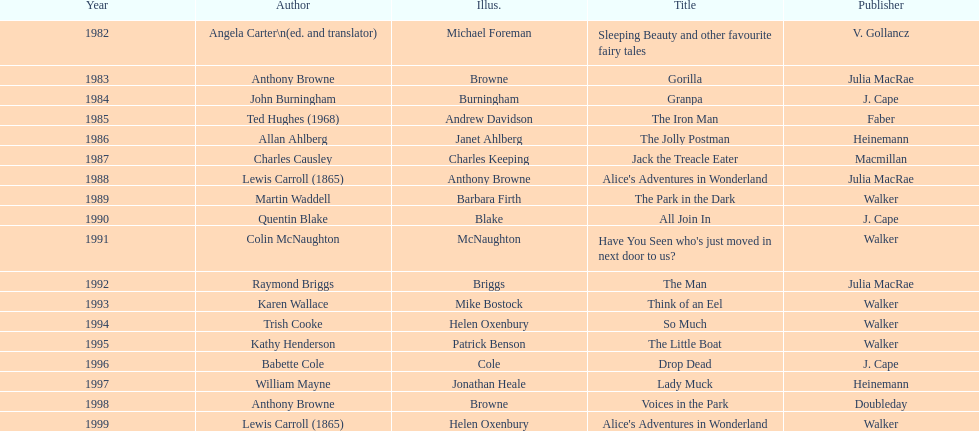How many titles had the same author listed as the illustrator? 7. 